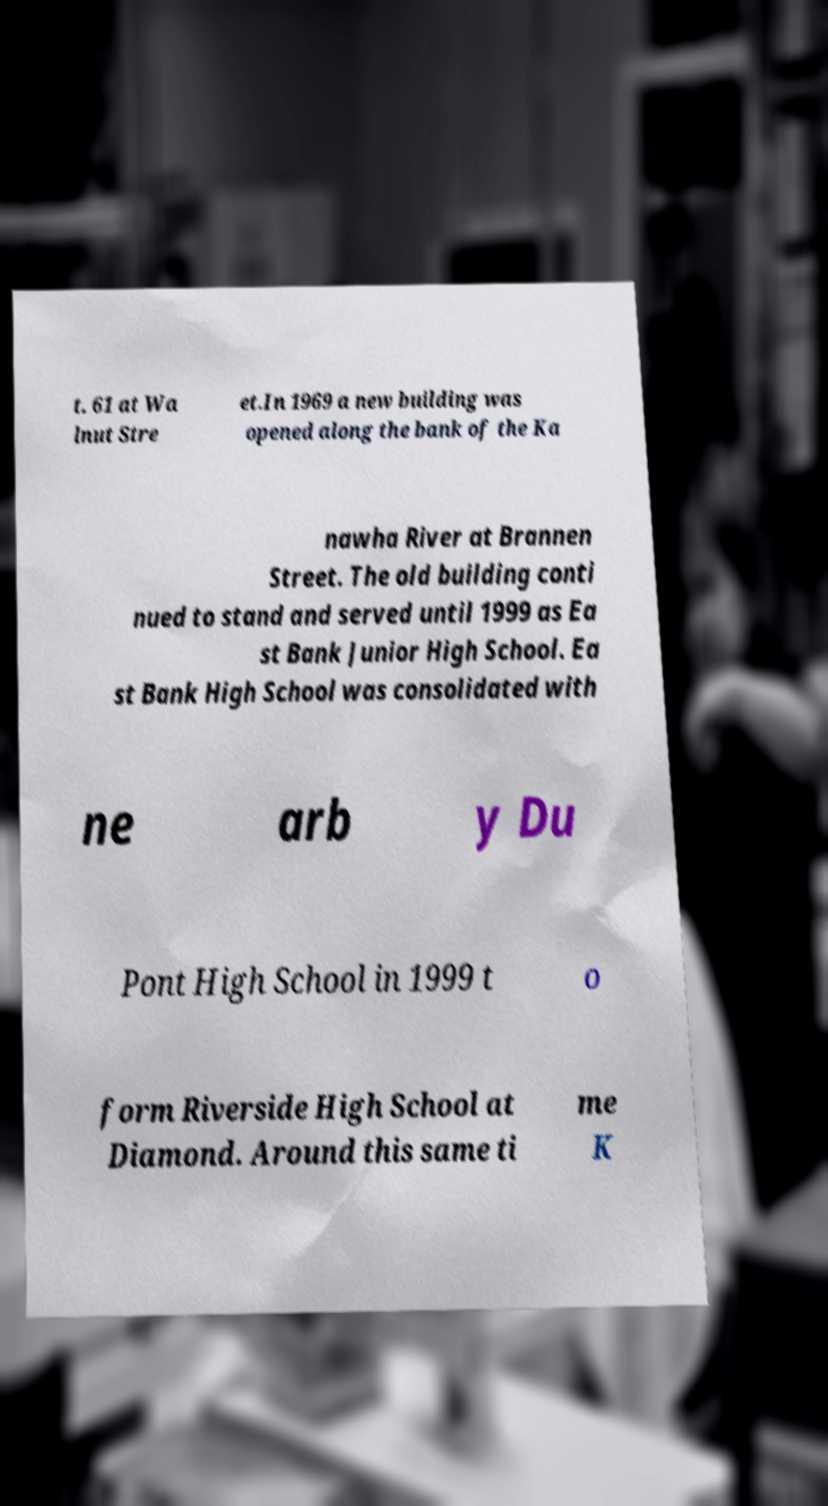Please identify and transcribe the text found in this image. t. 61 at Wa lnut Stre et.In 1969 a new building was opened along the bank of the Ka nawha River at Brannen Street. The old building conti nued to stand and served until 1999 as Ea st Bank Junior High School. Ea st Bank High School was consolidated with ne arb y Du Pont High School in 1999 t o form Riverside High School at Diamond. Around this same ti me K 